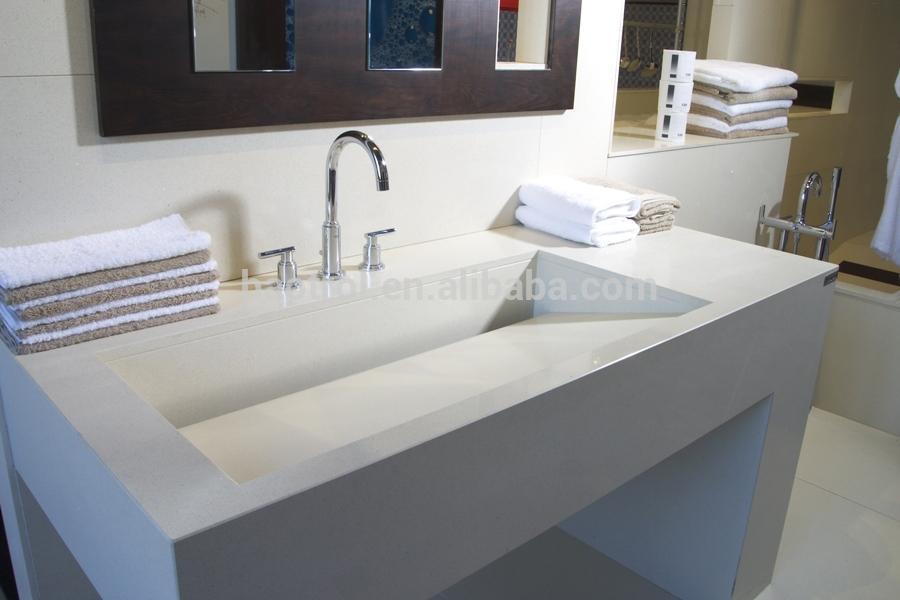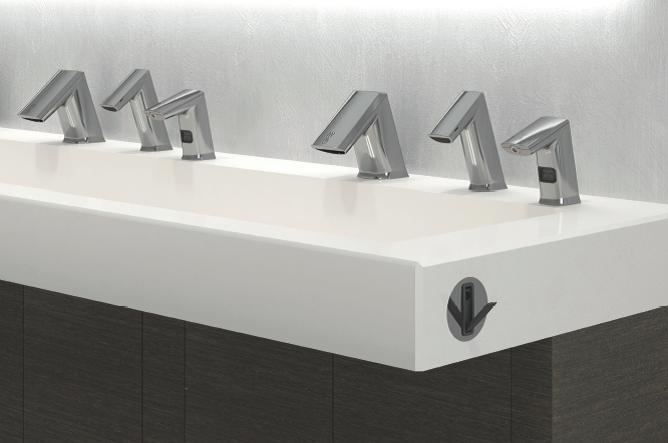The first image is the image on the left, the second image is the image on the right. Examine the images to the left and right. Is the description "Each image shows a white counter with a single undivided rectangular sink carved into it, and at least one image features a row of six spouts above the basin." accurate? Answer yes or no. Yes. 